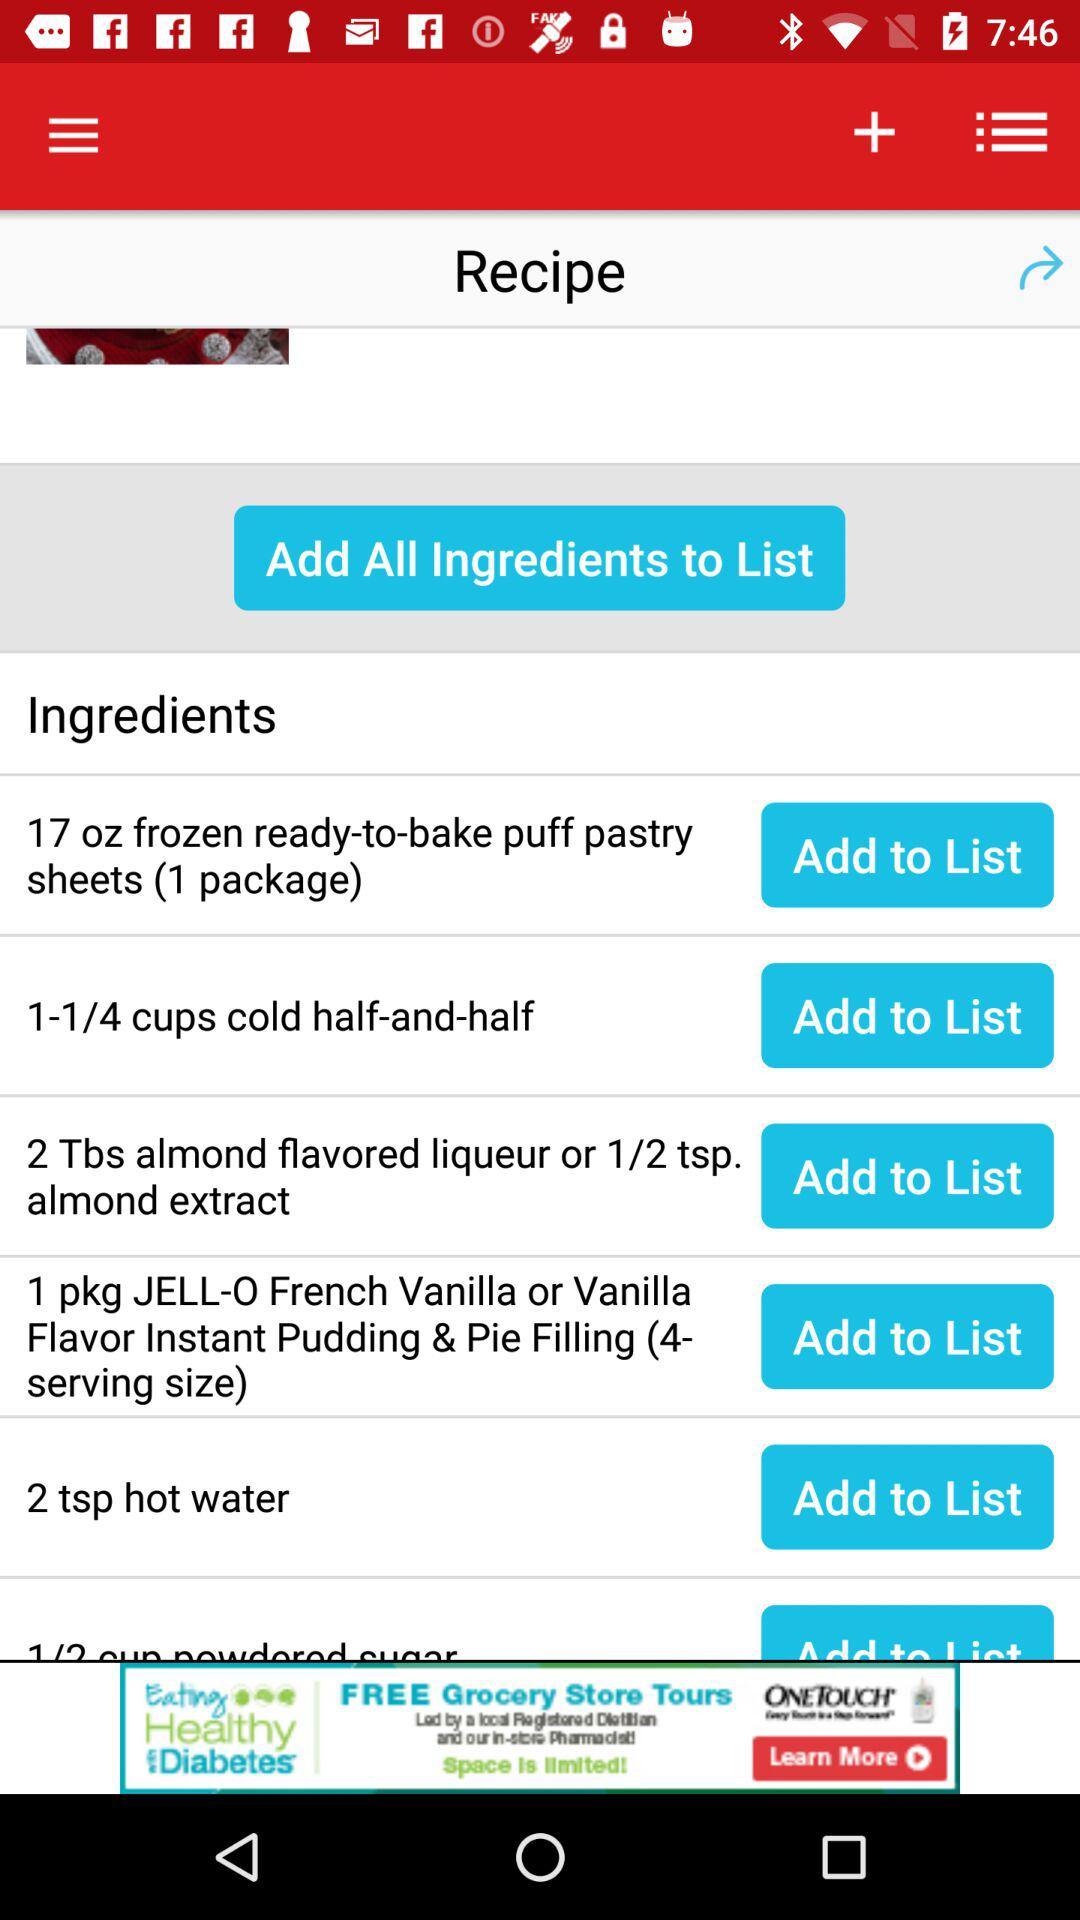How many ingredients are there in the recipe?
Answer the question using a single word or phrase. 6 